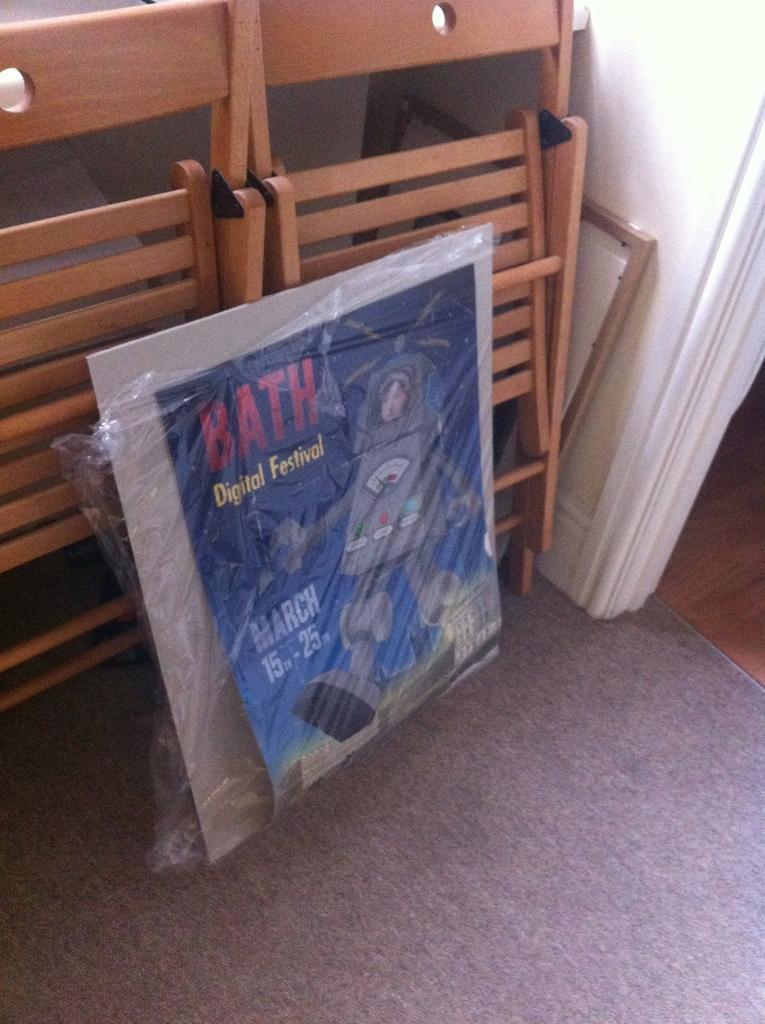What can be seen hanging on the wall in the image? There is a poster in the image. What type of objects are made of wood in the image? There are wooden objects in the image. What is the background of the image made of? There is a wall in the image. What is covering the floor in the image? There is a carpet at the bottom of the image. How many errors can be found on the poster in the image? There is no mention of errors on the poster in the image, and therefore it cannot be determined how many errors might be present. What type of comfort can be found in the wooden objects in the image? The wooden objects in the image are not associated with comfort, as they are inanimate objects. 